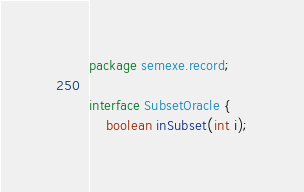<code> <loc_0><loc_0><loc_500><loc_500><_Java_>package semexe.record;

interface SubsetOracle {
    boolean inSubset(int i);
</code> 